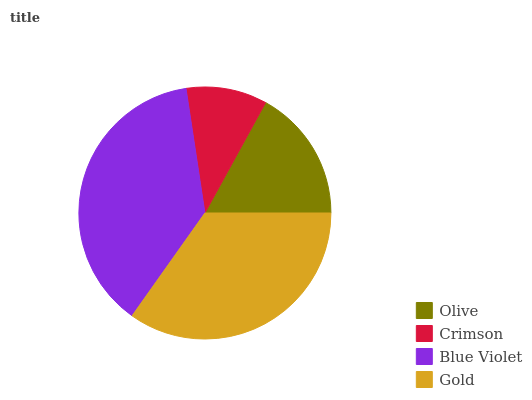Is Crimson the minimum?
Answer yes or no. Yes. Is Blue Violet the maximum?
Answer yes or no. Yes. Is Blue Violet the minimum?
Answer yes or no. No. Is Crimson the maximum?
Answer yes or no. No. Is Blue Violet greater than Crimson?
Answer yes or no. Yes. Is Crimson less than Blue Violet?
Answer yes or no. Yes. Is Crimson greater than Blue Violet?
Answer yes or no. No. Is Blue Violet less than Crimson?
Answer yes or no. No. Is Gold the high median?
Answer yes or no. Yes. Is Olive the low median?
Answer yes or no. Yes. Is Crimson the high median?
Answer yes or no. No. Is Crimson the low median?
Answer yes or no. No. 